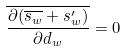Convert formula to latex. <formula><loc_0><loc_0><loc_500><loc_500>\overline { \frac { \partial ( \overline { s _ { w } } + s _ { w } ^ { \prime } ) } { \partial d _ { w } } } = 0</formula> 